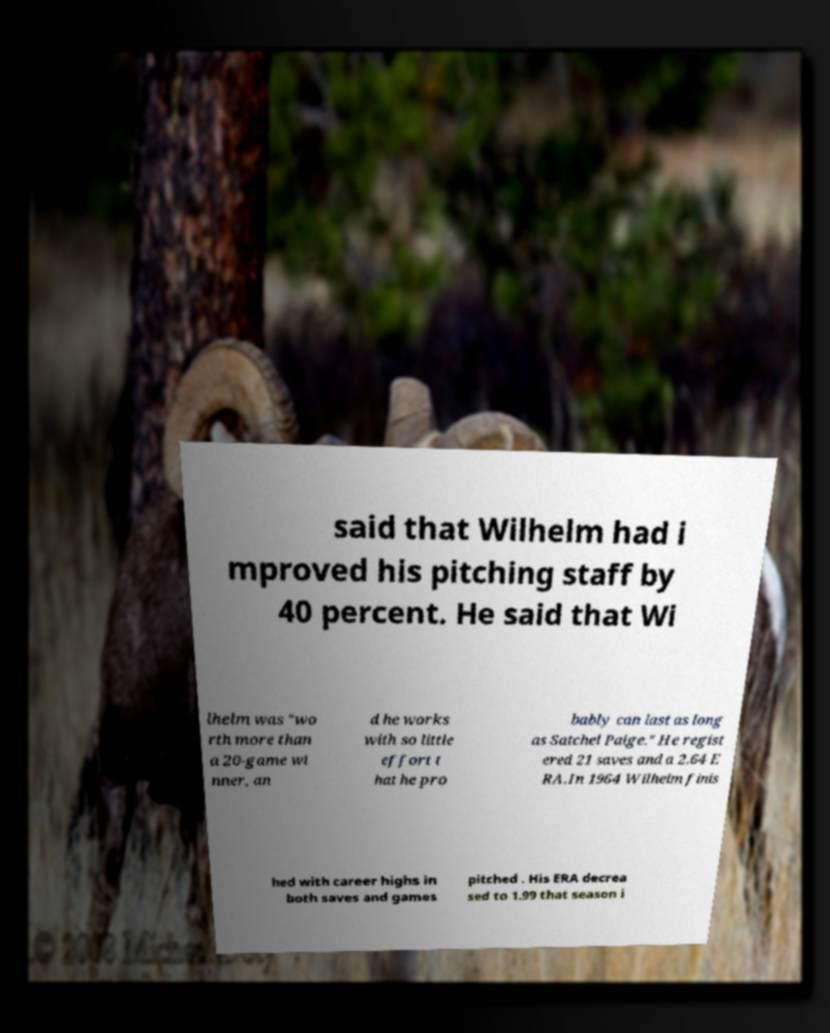For documentation purposes, I need the text within this image transcribed. Could you provide that? said that Wilhelm had i mproved his pitching staff by 40 percent. He said that Wi lhelm was "wo rth more than a 20-game wi nner, an d he works with so little effort t hat he pro bably can last as long as Satchel Paige." He regist ered 21 saves and a 2.64 E RA.In 1964 Wilhelm finis hed with career highs in both saves and games pitched . His ERA decrea sed to 1.99 that season i 